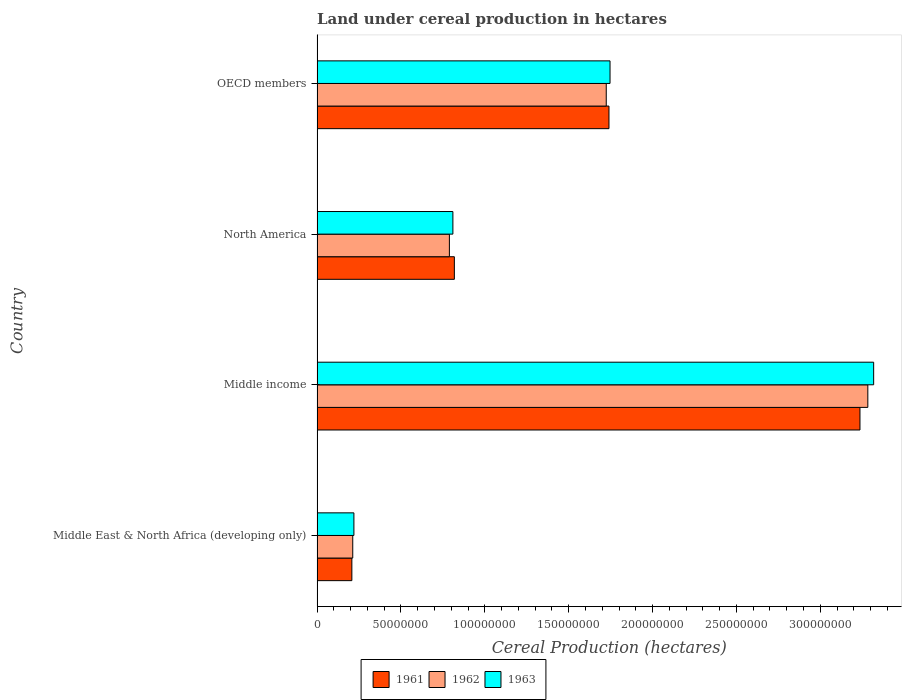How many different coloured bars are there?
Your answer should be very brief. 3. How many groups of bars are there?
Provide a succinct answer. 4. Are the number of bars on each tick of the Y-axis equal?
Your answer should be very brief. Yes. How many bars are there on the 3rd tick from the top?
Offer a terse response. 3. How many bars are there on the 2nd tick from the bottom?
Keep it short and to the point. 3. In how many cases, is the number of bars for a given country not equal to the number of legend labels?
Offer a very short reply. 0. What is the land under cereal production in 1962 in North America?
Offer a very short reply. 7.89e+07. Across all countries, what is the maximum land under cereal production in 1962?
Make the answer very short. 3.28e+08. Across all countries, what is the minimum land under cereal production in 1961?
Offer a terse response. 2.08e+07. In which country was the land under cereal production in 1963 minimum?
Offer a very short reply. Middle East & North Africa (developing only). What is the total land under cereal production in 1961 in the graph?
Your answer should be compact. 6.00e+08. What is the difference between the land under cereal production in 1963 in North America and that in OECD members?
Your response must be concise. -9.37e+07. What is the difference between the land under cereal production in 1962 in Middle income and the land under cereal production in 1961 in OECD members?
Your response must be concise. 1.54e+08. What is the average land under cereal production in 1962 per country?
Give a very brief answer. 1.50e+08. What is the difference between the land under cereal production in 1963 and land under cereal production in 1962 in Middle income?
Ensure brevity in your answer.  3.48e+06. In how many countries, is the land under cereal production in 1961 greater than 210000000 hectares?
Provide a short and direct response. 1. What is the ratio of the land under cereal production in 1961 in Middle income to that in OECD members?
Ensure brevity in your answer.  1.86. What is the difference between the highest and the second highest land under cereal production in 1961?
Ensure brevity in your answer.  1.50e+08. What is the difference between the highest and the lowest land under cereal production in 1961?
Provide a succinct answer. 3.03e+08. Is the sum of the land under cereal production in 1961 in Middle East & North Africa (developing only) and OECD members greater than the maximum land under cereal production in 1962 across all countries?
Provide a succinct answer. No. How many bars are there?
Provide a succinct answer. 12. How many countries are there in the graph?
Give a very brief answer. 4. Does the graph contain grids?
Make the answer very short. No. What is the title of the graph?
Ensure brevity in your answer.  Land under cereal production in hectares. Does "2007" appear as one of the legend labels in the graph?
Your answer should be very brief. No. What is the label or title of the X-axis?
Ensure brevity in your answer.  Cereal Production (hectares). What is the Cereal Production (hectares) of 1961 in Middle East & North Africa (developing only)?
Offer a terse response. 2.08e+07. What is the Cereal Production (hectares) in 1962 in Middle East & North Africa (developing only)?
Your response must be concise. 2.13e+07. What is the Cereal Production (hectares) in 1963 in Middle East & North Africa (developing only)?
Give a very brief answer. 2.20e+07. What is the Cereal Production (hectares) of 1961 in Middle income?
Give a very brief answer. 3.24e+08. What is the Cereal Production (hectares) in 1962 in Middle income?
Keep it short and to the point. 3.28e+08. What is the Cereal Production (hectares) of 1963 in Middle income?
Offer a very short reply. 3.32e+08. What is the Cereal Production (hectares) of 1961 in North America?
Ensure brevity in your answer.  8.19e+07. What is the Cereal Production (hectares) in 1962 in North America?
Offer a very short reply. 7.89e+07. What is the Cereal Production (hectares) of 1963 in North America?
Your answer should be very brief. 8.10e+07. What is the Cereal Production (hectares) of 1961 in OECD members?
Provide a succinct answer. 1.74e+08. What is the Cereal Production (hectares) of 1962 in OECD members?
Your answer should be compact. 1.72e+08. What is the Cereal Production (hectares) of 1963 in OECD members?
Your answer should be very brief. 1.75e+08. Across all countries, what is the maximum Cereal Production (hectares) in 1961?
Provide a succinct answer. 3.24e+08. Across all countries, what is the maximum Cereal Production (hectares) in 1962?
Offer a terse response. 3.28e+08. Across all countries, what is the maximum Cereal Production (hectares) in 1963?
Your answer should be compact. 3.32e+08. Across all countries, what is the minimum Cereal Production (hectares) of 1961?
Provide a succinct answer. 2.08e+07. Across all countries, what is the minimum Cereal Production (hectares) of 1962?
Your response must be concise. 2.13e+07. Across all countries, what is the minimum Cereal Production (hectares) of 1963?
Keep it short and to the point. 2.20e+07. What is the total Cereal Production (hectares) of 1961 in the graph?
Provide a short and direct response. 6.00e+08. What is the total Cereal Production (hectares) of 1962 in the graph?
Offer a terse response. 6.01e+08. What is the total Cereal Production (hectares) of 1963 in the graph?
Keep it short and to the point. 6.09e+08. What is the difference between the Cereal Production (hectares) in 1961 in Middle East & North Africa (developing only) and that in Middle income?
Your answer should be compact. -3.03e+08. What is the difference between the Cereal Production (hectares) of 1962 in Middle East & North Africa (developing only) and that in Middle income?
Your answer should be compact. -3.07e+08. What is the difference between the Cereal Production (hectares) of 1963 in Middle East & North Africa (developing only) and that in Middle income?
Provide a succinct answer. -3.10e+08. What is the difference between the Cereal Production (hectares) of 1961 in Middle East & North Africa (developing only) and that in North America?
Keep it short and to the point. -6.11e+07. What is the difference between the Cereal Production (hectares) of 1962 in Middle East & North Africa (developing only) and that in North America?
Your answer should be very brief. -5.76e+07. What is the difference between the Cereal Production (hectares) of 1963 in Middle East & North Africa (developing only) and that in North America?
Your answer should be very brief. -5.90e+07. What is the difference between the Cereal Production (hectares) in 1961 in Middle East & North Africa (developing only) and that in OECD members?
Your answer should be compact. -1.53e+08. What is the difference between the Cereal Production (hectares) in 1962 in Middle East & North Africa (developing only) and that in OECD members?
Provide a short and direct response. -1.51e+08. What is the difference between the Cereal Production (hectares) of 1963 in Middle East & North Africa (developing only) and that in OECD members?
Offer a very short reply. -1.53e+08. What is the difference between the Cereal Production (hectares) in 1961 in Middle income and that in North America?
Ensure brevity in your answer.  2.42e+08. What is the difference between the Cereal Production (hectares) in 1962 in Middle income and that in North America?
Your answer should be compact. 2.49e+08. What is the difference between the Cereal Production (hectares) of 1963 in Middle income and that in North America?
Your answer should be very brief. 2.51e+08. What is the difference between the Cereal Production (hectares) of 1961 in Middle income and that in OECD members?
Keep it short and to the point. 1.50e+08. What is the difference between the Cereal Production (hectares) in 1962 in Middle income and that in OECD members?
Your response must be concise. 1.56e+08. What is the difference between the Cereal Production (hectares) in 1963 in Middle income and that in OECD members?
Offer a very short reply. 1.57e+08. What is the difference between the Cereal Production (hectares) in 1961 in North America and that in OECD members?
Give a very brief answer. -9.22e+07. What is the difference between the Cereal Production (hectares) of 1962 in North America and that in OECD members?
Your response must be concise. -9.35e+07. What is the difference between the Cereal Production (hectares) of 1963 in North America and that in OECD members?
Your answer should be very brief. -9.37e+07. What is the difference between the Cereal Production (hectares) of 1961 in Middle East & North Africa (developing only) and the Cereal Production (hectares) of 1962 in Middle income?
Your answer should be very brief. -3.08e+08. What is the difference between the Cereal Production (hectares) of 1961 in Middle East & North Africa (developing only) and the Cereal Production (hectares) of 1963 in Middle income?
Your answer should be compact. -3.11e+08. What is the difference between the Cereal Production (hectares) in 1962 in Middle East & North Africa (developing only) and the Cereal Production (hectares) in 1963 in Middle income?
Your answer should be compact. -3.11e+08. What is the difference between the Cereal Production (hectares) of 1961 in Middle East & North Africa (developing only) and the Cereal Production (hectares) of 1962 in North America?
Provide a short and direct response. -5.81e+07. What is the difference between the Cereal Production (hectares) in 1961 in Middle East & North Africa (developing only) and the Cereal Production (hectares) in 1963 in North America?
Keep it short and to the point. -6.02e+07. What is the difference between the Cereal Production (hectares) in 1962 in Middle East & North Africa (developing only) and the Cereal Production (hectares) in 1963 in North America?
Offer a very short reply. -5.97e+07. What is the difference between the Cereal Production (hectares) of 1961 in Middle East & North Africa (developing only) and the Cereal Production (hectares) of 1962 in OECD members?
Offer a terse response. -1.52e+08. What is the difference between the Cereal Production (hectares) of 1961 in Middle East & North Africa (developing only) and the Cereal Production (hectares) of 1963 in OECD members?
Keep it short and to the point. -1.54e+08. What is the difference between the Cereal Production (hectares) in 1962 in Middle East & North Africa (developing only) and the Cereal Production (hectares) in 1963 in OECD members?
Your answer should be compact. -1.53e+08. What is the difference between the Cereal Production (hectares) of 1961 in Middle income and the Cereal Production (hectares) of 1962 in North America?
Keep it short and to the point. 2.45e+08. What is the difference between the Cereal Production (hectares) in 1961 in Middle income and the Cereal Production (hectares) in 1963 in North America?
Your response must be concise. 2.43e+08. What is the difference between the Cereal Production (hectares) of 1962 in Middle income and the Cereal Production (hectares) of 1963 in North America?
Provide a short and direct response. 2.47e+08. What is the difference between the Cereal Production (hectares) in 1961 in Middle income and the Cereal Production (hectares) in 1962 in OECD members?
Your answer should be very brief. 1.51e+08. What is the difference between the Cereal Production (hectares) of 1961 in Middle income and the Cereal Production (hectares) of 1963 in OECD members?
Keep it short and to the point. 1.49e+08. What is the difference between the Cereal Production (hectares) in 1962 in Middle income and the Cereal Production (hectares) in 1963 in OECD members?
Keep it short and to the point. 1.54e+08. What is the difference between the Cereal Production (hectares) in 1961 in North America and the Cereal Production (hectares) in 1962 in OECD members?
Keep it short and to the point. -9.06e+07. What is the difference between the Cereal Production (hectares) of 1961 in North America and the Cereal Production (hectares) of 1963 in OECD members?
Make the answer very short. -9.28e+07. What is the difference between the Cereal Production (hectares) of 1962 in North America and the Cereal Production (hectares) of 1963 in OECD members?
Provide a succinct answer. -9.58e+07. What is the average Cereal Production (hectares) of 1961 per country?
Provide a succinct answer. 1.50e+08. What is the average Cereal Production (hectares) of 1962 per country?
Provide a succinct answer. 1.50e+08. What is the average Cereal Production (hectares) of 1963 per country?
Make the answer very short. 1.52e+08. What is the difference between the Cereal Production (hectares) in 1961 and Cereal Production (hectares) in 1962 in Middle East & North Africa (developing only)?
Offer a terse response. -5.29e+05. What is the difference between the Cereal Production (hectares) in 1961 and Cereal Production (hectares) in 1963 in Middle East & North Africa (developing only)?
Ensure brevity in your answer.  -1.22e+06. What is the difference between the Cereal Production (hectares) in 1962 and Cereal Production (hectares) in 1963 in Middle East & North Africa (developing only)?
Make the answer very short. -6.86e+05. What is the difference between the Cereal Production (hectares) of 1961 and Cereal Production (hectares) of 1962 in Middle income?
Provide a short and direct response. -4.68e+06. What is the difference between the Cereal Production (hectares) of 1961 and Cereal Production (hectares) of 1963 in Middle income?
Your response must be concise. -8.16e+06. What is the difference between the Cereal Production (hectares) in 1962 and Cereal Production (hectares) in 1963 in Middle income?
Keep it short and to the point. -3.48e+06. What is the difference between the Cereal Production (hectares) of 1961 and Cereal Production (hectares) of 1962 in North America?
Give a very brief answer. 2.97e+06. What is the difference between the Cereal Production (hectares) of 1961 and Cereal Production (hectares) of 1963 in North America?
Offer a very short reply. 8.78e+05. What is the difference between the Cereal Production (hectares) in 1962 and Cereal Production (hectares) in 1963 in North America?
Provide a short and direct response. -2.09e+06. What is the difference between the Cereal Production (hectares) of 1961 and Cereal Production (hectares) of 1962 in OECD members?
Offer a terse response. 1.62e+06. What is the difference between the Cereal Production (hectares) of 1961 and Cereal Production (hectares) of 1963 in OECD members?
Provide a short and direct response. -6.28e+05. What is the difference between the Cereal Production (hectares) of 1962 and Cereal Production (hectares) of 1963 in OECD members?
Your answer should be compact. -2.25e+06. What is the ratio of the Cereal Production (hectares) in 1961 in Middle East & North Africa (developing only) to that in Middle income?
Make the answer very short. 0.06. What is the ratio of the Cereal Production (hectares) in 1962 in Middle East & North Africa (developing only) to that in Middle income?
Your response must be concise. 0.06. What is the ratio of the Cereal Production (hectares) of 1963 in Middle East & North Africa (developing only) to that in Middle income?
Make the answer very short. 0.07. What is the ratio of the Cereal Production (hectares) in 1961 in Middle East & North Africa (developing only) to that in North America?
Your answer should be compact. 0.25. What is the ratio of the Cereal Production (hectares) in 1962 in Middle East & North Africa (developing only) to that in North America?
Offer a terse response. 0.27. What is the ratio of the Cereal Production (hectares) of 1963 in Middle East & North Africa (developing only) to that in North America?
Ensure brevity in your answer.  0.27. What is the ratio of the Cereal Production (hectares) in 1961 in Middle East & North Africa (developing only) to that in OECD members?
Offer a terse response. 0.12. What is the ratio of the Cereal Production (hectares) in 1962 in Middle East & North Africa (developing only) to that in OECD members?
Make the answer very short. 0.12. What is the ratio of the Cereal Production (hectares) of 1963 in Middle East & North Africa (developing only) to that in OECD members?
Provide a short and direct response. 0.13. What is the ratio of the Cereal Production (hectares) in 1961 in Middle income to that in North America?
Keep it short and to the point. 3.95. What is the ratio of the Cereal Production (hectares) in 1962 in Middle income to that in North America?
Your answer should be very brief. 4.16. What is the ratio of the Cereal Production (hectares) of 1963 in Middle income to that in North America?
Provide a succinct answer. 4.1. What is the ratio of the Cereal Production (hectares) of 1961 in Middle income to that in OECD members?
Ensure brevity in your answer.  1.86. What is the ratio of the Cereal Production (hectares) of 1962 in Middle income to that in OECD members?
Ensure brevity in your answer.  1.9. What is the ratio of the Cereal Production (hectares) of 1963 in Middle income to that in OECD members?
Ensure brevity in your answer.  1.9. What is the ratio of the Cereal Production (hectares) in 1961 in North America to that in OECD members?
Make the answer very short. 0.47. What is the ratio of the Cereal Production (hectares) in 1962 in North America to that in OECD members?
Offer a terse response. 0.46. What is the ratio of the Cereal Production (hectares) in 1963 in North America to that in OECD members?
Offer a very short reply. 0.46. What is the difference between the highest and the second highest Cereal Production (hectares) in 1961?
Your answer should be very brief. 1.50e+08. What is the difference between the highest and the second highest Cereal Production (hectares) of 1962?
Provide a short and direct response. 1.56e+08. What is the difference between the highest and the second highest Cereal Production (hectares) in 1963?
Give a very brief answer. 1.57e+08. What is the difference between the highest and the lowest Cereal Production (hectares) of 1961?
Ensure brevity in your answer.  3.03e+08. What is the difference between the highest and the lowest Cereal Production (hectares) of 1962?
Offer a very short reply. 3.07e+08. What is the difference between the highest and the lowest Cereal Production (hectares) of 1963?
Your answer should be compact. 3.10e+08. 